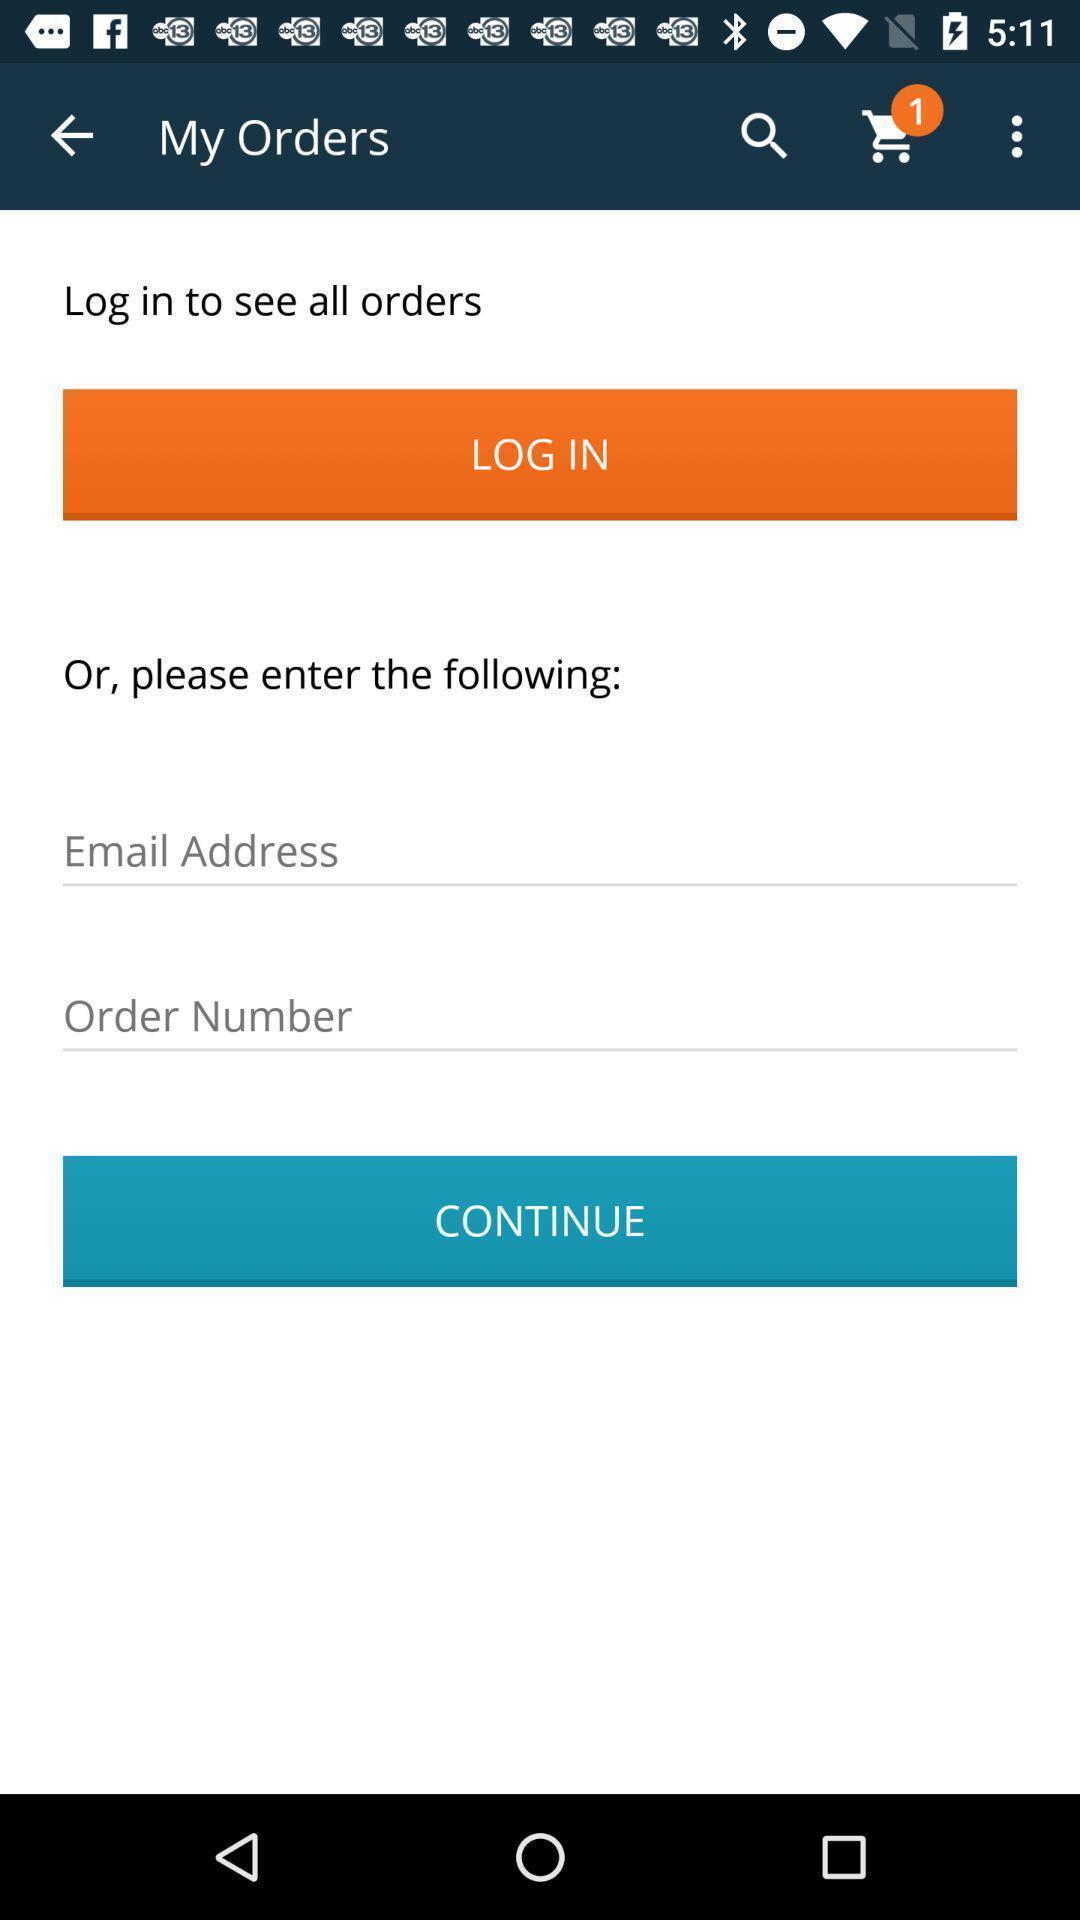Describe the key features of this screenshot. Page asking for the login credentials. 